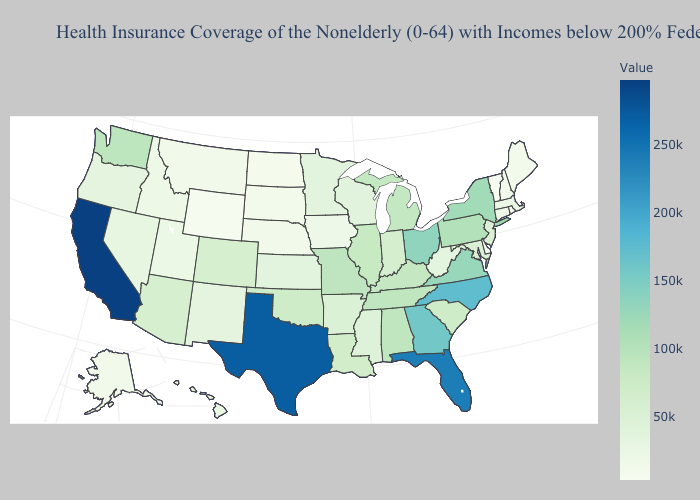Among the states that border New Jersey , does Delaware have the lowest value?
Write a very short answer. Yes. Does Delaware have the lowest value in the South?
Quick response, please. Yes. Does the map have missing data?
Write a very short answer. No. Is the legend a continuous bar?
Write a very short answer. Yes. Among the states that border North Carolina , which have the highest value?
Keep it brief. Georgia. Does Colorado have the highest value in the USA?
Concise answer only. No. Among the states that border Delaware , does New Jersey have the lowest value?
Give a very brief answer. Yes. Does Maryland have a higher value than Texas?
Concise answer only. No. Does Arkansas have the lowest value in the USA?
Answer briefly. No. Does Delaware have the lowest value in the USA?
Keep it brief. No. 